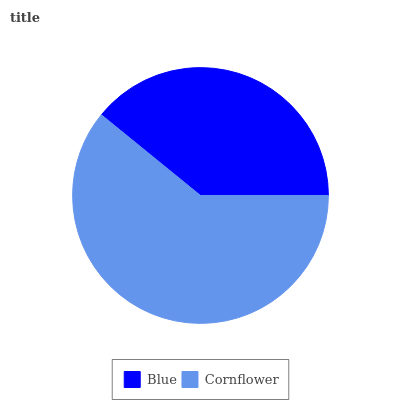Is Blue the minimum?
Answer yes or no. Yes. Is Cornflower the maximum?
Answer yes or no. Yes. Is Cornflower the minimum?
Answer yes or no. No. Is Cornflower greater than Blue?
Answer yes or no. Yes. Is Blue less than Cornflower?
Answer yes or no. Yes. Is Blue greater than Cornflower?
Answer yes or no. No. Is Cornflower less than Blue?
Answer yes or no. No. Is Cornflower the high median?
Answer yes or no. Yes. Is Blue the low median?
Answer yes or no. Yes. Is Blue the high median?
Answer yes or no. No. Is Cornflower the low median?
Answer yes or no. No. 